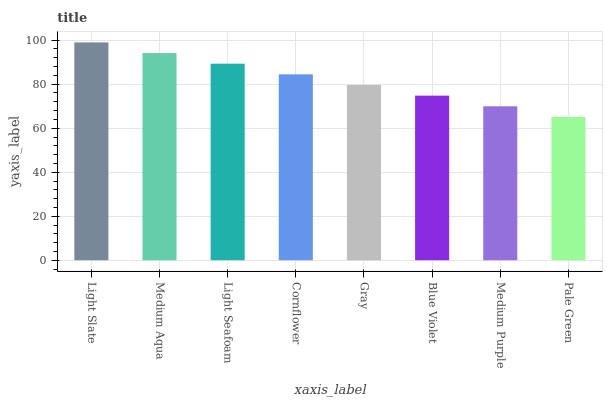Is Pale Green the minimum?
Answer yes or no. Yes. Is Light Slate the maximum?
Answer yes or no. Yes. Is Medium Aqua the minimum?
Answer yes or no. No. Is Medium Aqua the maximum?
Answer yes or no. No. Is Light Slate greater than Medium Aqua?
Answer yes or no. Yes. Is Medium Aqua less than Light Slate?
Answer yes or no. Yes. Is Medium Aqua greater than Light Slate?
Answer yes or no. No. Is Light Slate less than Medium Aqua?
Answer yes or no. No. Is Cornflower the high median?
Answer yes or no. Yes. Is Gray the low median?
Answer yes or no. Yes. Is Pale Green the high median?
Answer yes or no. No. Is Pale Green the low median?
Answer yes or no. No. 